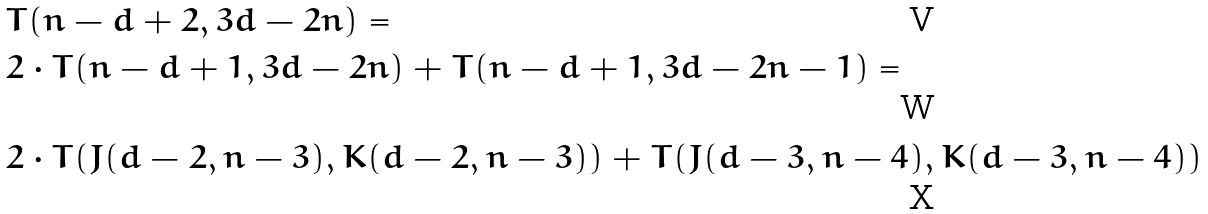Convert formula to latex. <formula><loc_0><loc_0><loc_500><loc_500>& T ( n - d + 2 , 3 d - 2 n ) = \\ & 2 \cdot T ( n - d + 1 , 3 d - 2 n ) + T ( n - d + 1 , 3 d - 2 n - 1 ) = \\ & 2 \cdot T ( J ( d - 2 , n - 3 ) , K ( d - 2 , n - 3 ) ) + T ( J ( d - 3 , n - 4 ) , K ( d - 3 , n - 4 ) )</formula> 